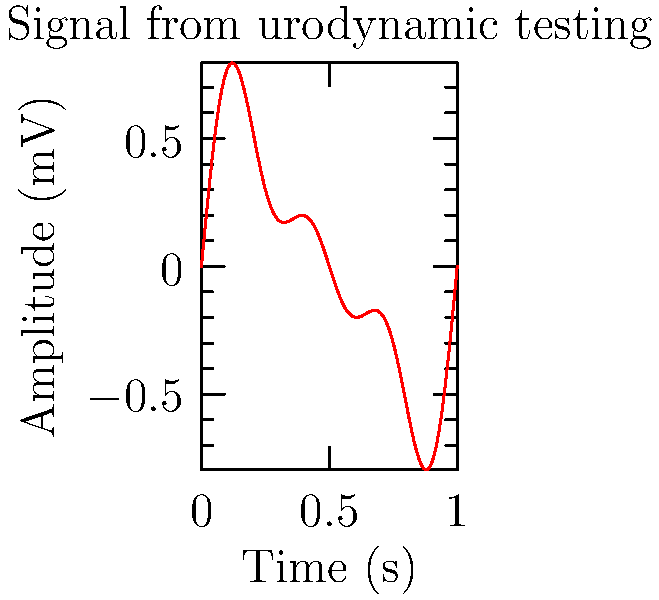A urodynamic testing equipment produces an electrical signal represented by the function:

$$ f(t) = 0.5\sin(2\pi t) + 0.3\sin(4\pi t) + 0.2\sin(6\pi t) $$

where $t$ is time in seconds and $f(t)$ is the amplitude in millivolts. What is the fundamental frequency of this signal? To find the fundamental frequency of this signal, we need to follow these steps:

1) The given function is a sum of three sinusoidal components:
   $$ f(t) = 0.5\sin(2\pi t) + 0.3\sin(4\pi t) + 0.2\sin(6\pi t) $$

2) In general, a sinusoidal function is of the form $\sin(2\pi ft)$, where $f$ is the frequency.

3) For the first component: $0.5\sin(2\pi t)$
   The frequency is 1 Hz (as $2\pi t = 2\pi \cdot 1 \cdot t$)

4) For the second component: $0.3\sin(4\pi t)$
   The frequency is 2 Hz (as $4\pi t = 2\pi \cdot 2 \cdot t$)

5) For the third component: $0.2\sin(6\pi t)$
   The frequency is 3 Hz (as $6\pi t = 2\pi \cdot 3 \cdot t$)

6) The fundamental frequency is the lowest frequency among these components.

Therefore, the fundamental frequency of this signal is 1 Hz.
Answer: 1 Hz 